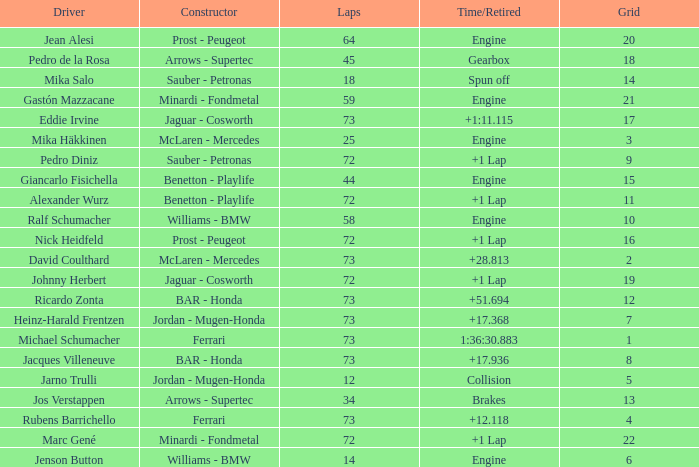How many laps did Giancarlo Fisichella do with a grid larger than 15? 0.0. 